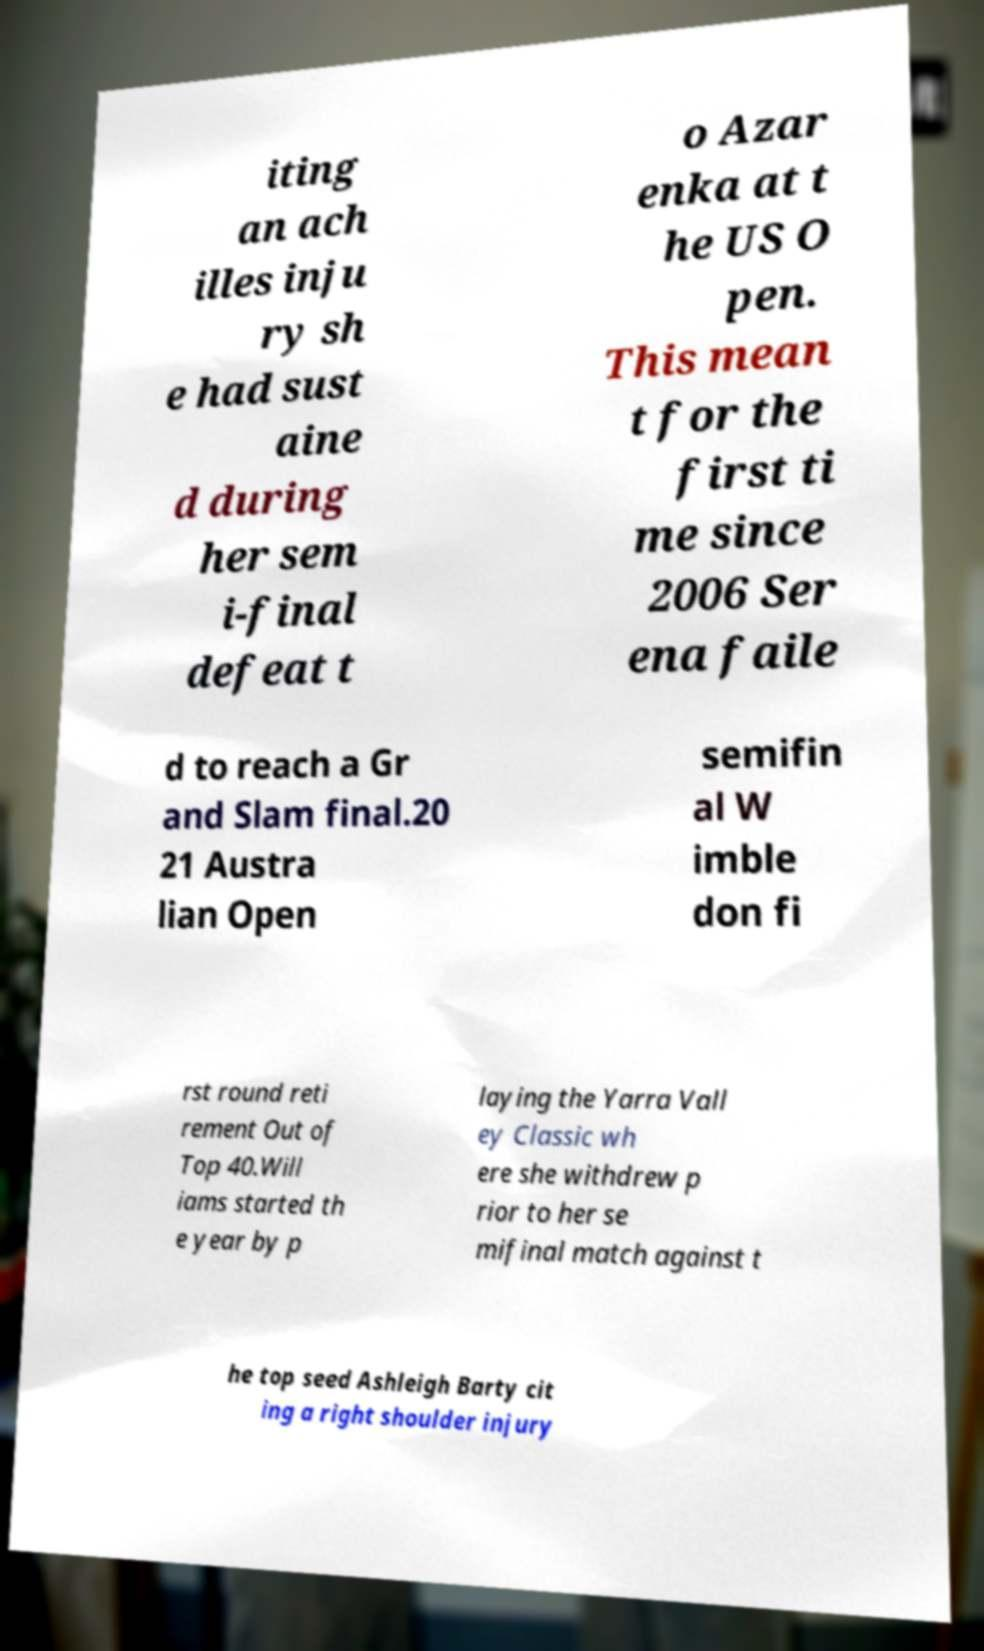Can you accurately transcribe the text from the provided image for me? iting an ach illes inju ry sh e had sust aine d during her sem i-final defeat t o Azar enka at t he US O pen. This mean t for the first ti me since 2006 Ser ena faile d to reach a Gr and Slam final.20 21 Austra lian Open semifin al W imble don fi rst round reti rement Out of Top 40.Will iams started th e year by p laying the Yarra Vall ey Classic wh ere she withdrew p rior to her se mifinal match against t he top seed Ashleigh Barty cit ing a right shoulder injury 